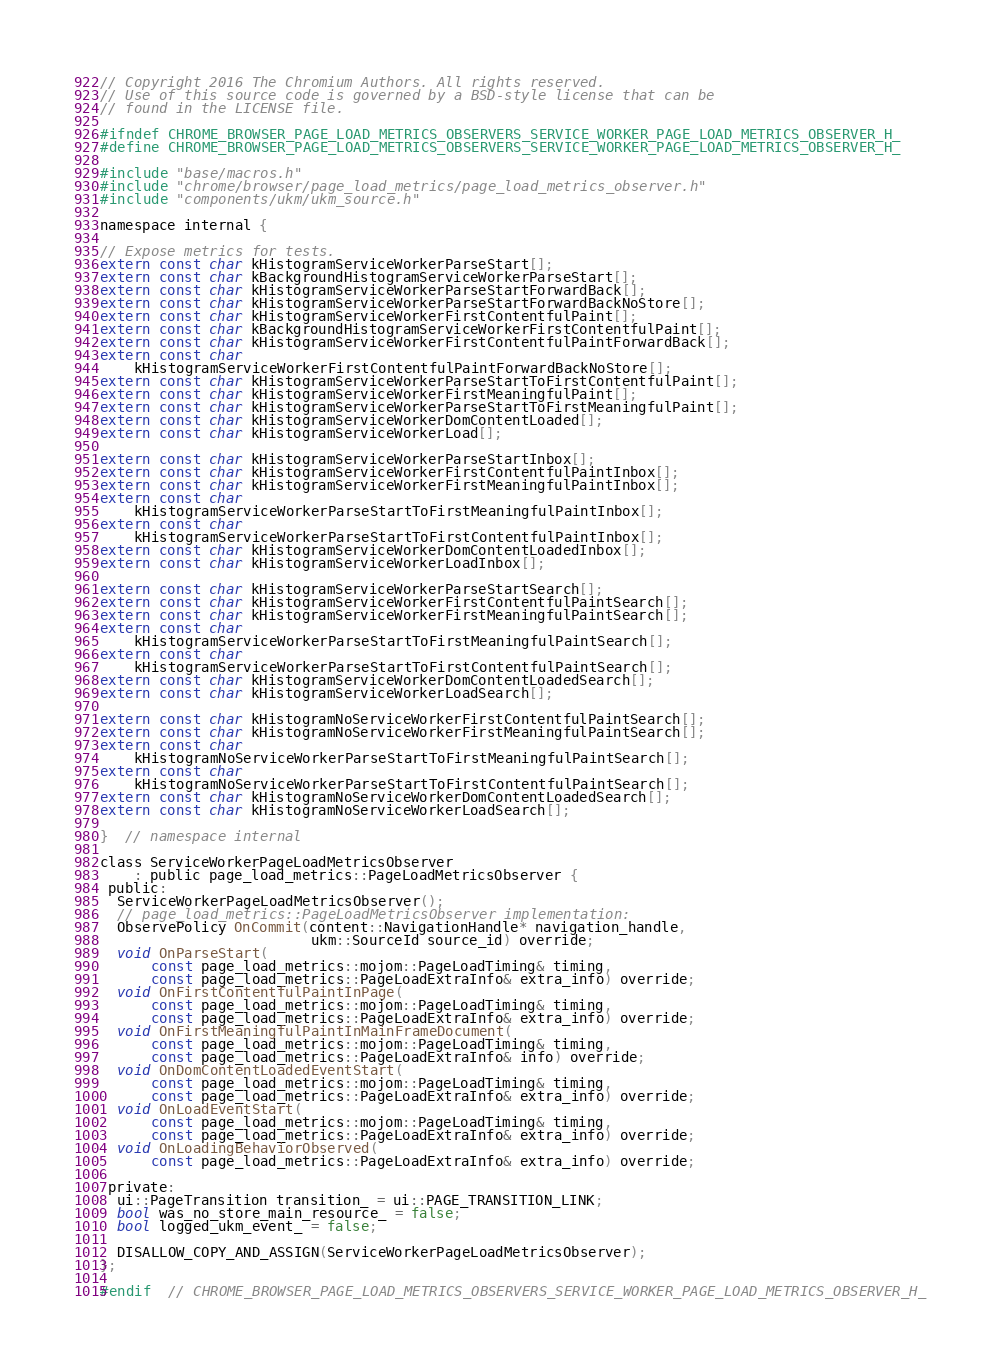Convert code to text. <code><loc_0><loc_0><loc_500><loc_500><_C_>// Copyright 2016 The Chromium Authors. All rights reserved.
// Use of this source code is governed by a BSD-style license that can be
// found in the LICENSE file.

#ifndef CHROME_BROWSER_PAGE_LOAD_METRICS_OBSERVERS_SERVICE_WORKER_PAGE_LOAD_METRICS_OBSERVER_H_
#define CHROME_BROWSER_PAGE_LOAD_METRICS_OBSERVERS_SERVICE_WORKER_PAGE_LOAD_METRICS_OBSERVER_H_

#include "base/macros.h"
#include "chrome/browser/page_load_metrics/page_load_metrics_observer.h"
#include "components/ukm/ukm_source.h"

namespace internal {

// Expose metrics for tests.
extern const char kHistogramServiceWorkerParseStart[];
extern const char kBackgroundHistogramServiceWorkerParseStart[];
extern const char kHistogramServiceWorkerParseStartForwardBack[];
extern const char kHistogramServiceWorkerParseStartForwardBackNoStore[];
extern const char kHistogramServiceWorkerFirstContentfulPaint[];
extern const char kBackgroundHistogramServiceWorkerFirstContentfulPaint[];
extern const char kHistogramServiceWorkerFirstContentfulPaintForwardBack[];
extern const char
    kHistogramServiceWorkerFirstContentfulPaintForwardBackNoStore[];
extern const char kHistogramServiceWorkerParseStartToFirstContentfulPaint[];
extern const char kHistogramServiceWorkerFirstMeaningfulPaint[];
extern const char kHistogramServiceWorkerParseStartToFirstMeaningfulPaint[];
extern const char kHistogramServiceWorkerDomContentLoaded[];
extern const char kHistogramServiceWorkerLoad[];

extern const char kHistogramServiceWorkerParseStartInbox[];
extern const char kHistogramServiceWorkerFirstContentfulPaintInbox[];
extern const char kHistogramServiceWorkerFirstMeaningfulPaintInbox[];
extern const char
    kHistogramServiceWorkerParseStartToFirstMeaningfulPaintInbox[];
extern const char
    kHistogramServiceWorkerParseStartToFirstContentfulPaintInbox[];
extern const char kHistogramServiceWorkerDomContentLoadedInbox[];
extern const char kHistogramServiceWorkerLoadInbox[];

extern const char kHistogramServiceWorkerParseStartSearch[];
extern const char kHistogramServiceWorkerFirstContentfulPaintSearch[];
extern const char kHistogramServiceWorkerFirstMeaningfulPaintSearch[];
extern const char
    kHistogramServiceWorkerParseStartToFirstMeaningfulPaintSearch[];
extern const char
    kHistogramServiceWorkerParseStartToFirstContentfulPaintSearch[];
extern const char kHistogramServiceWorkerDomContentLoadedSearch[];
extern const char kHistogramServiceWorkerLoadSearch[];

extern const char kHistogramNoServiceWorkerFirstContentfulPaintSearch[];
extern const char kHistogramNoServiceWorkerFirstMeaningfulPaintSearch[];
extern const char
    kHistogramNoServiceWorkerParseStartToFirstMeaningfulPaintSearch[];
extern const char
    kHistogramNoServiceWorkerParseStartToFirstContentfulPaintSearch[];
extern const char kHistogramNoServiceWorkerDomContentLoadedSearch[];
extern const char kHistogramNoServiceWorkerLoadSearch[];

}  // namespace internal

class ServiceWorkerPageLoadMetricsObserver
    : public page_load_metrics::PageLoadMetricsObserver {
 public:
  ServiceWorkerPageLoadMetricsObserver();
  // page_load_metrics::PageLoadMetricsObserver implementation:
  ObservePolicy OnCommit(content::NavigationHandle* navigation_handle,
                         ukm::SourceId source_id) override;
  void OnParseStart(
      const page_load_metrics::mojom::PageLoadTiming& timing,
      const page_load_metrics::PageLoadExtraInfo& extra_info) override;
  void OnFirstContentfulPaintInPage(
      const page_load_metrics::mojom::PageLoadTiming& timing,
      const page_load_metrics::PageLoadExtraInfo& extra_info) override;
  void OnFirstMeaningfulPaintInMainFrameDocument(
      const page_load_metrics::mojom::PageLoadTiming& timing,
      const page_load_metrics::PageLoadExtraInfo& info) override;
  void OnDomContentLoadedEventStart(
      const page_load_metrics::mojom::PageLoadTiming& timing,
      const page_load_metrics::PageLoadExtraInfo& extra_info) override;
  void OnLoadEventStart(
      const page_load_metrics::mojom::PageLoadTiming& timing,
      const page_load_metrics::PageLoadExtraInfo& extra_info) override;
  void OnLoadingBehaviorObserved(
      const page_load_metrics::PageLoadExtraInfo& extra_info) override;

 private:
  ui::PageTransition transition_ = ui::PAGE_TRANSITION_LINK;
  bool was_no_store_main_resource_ = false;
  bool logged_ukm_event_ = false;

  DISALLOW_COPY_AND_ASSIGN(ServiceWorkerPageLoadMetricsObserver);
};

#endif  // CHROME_BROWSER_PAGE_LOAD_METRICS_OBSERVERS_SERVICE_WORKER_PAGE_LOAD_METRICS_OBSERVER_H_
</code> 